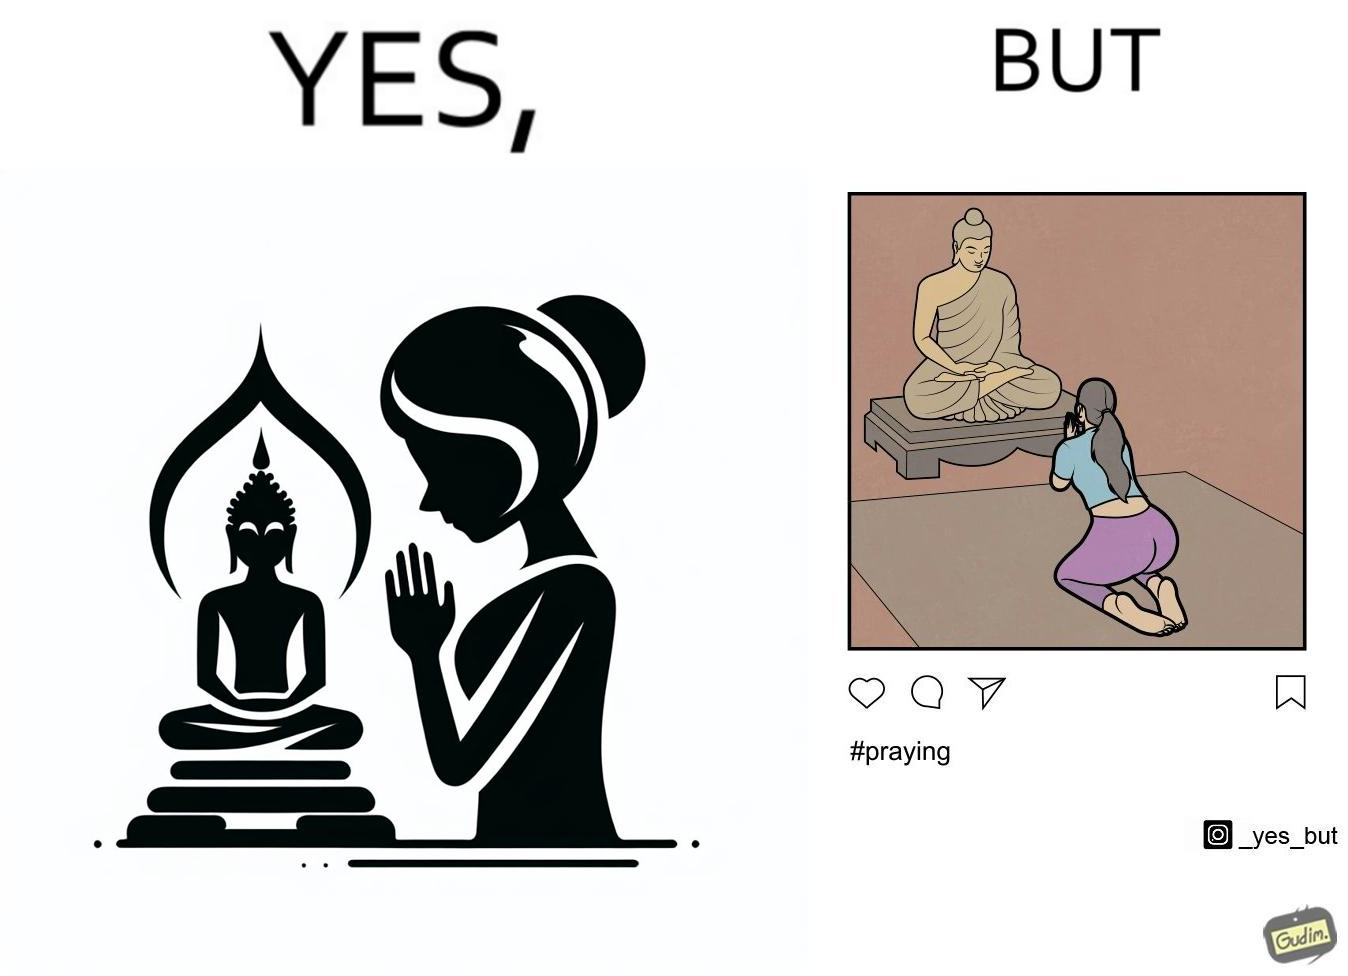Is this image satirical or non-satirical? Yes, this image is satirical. 